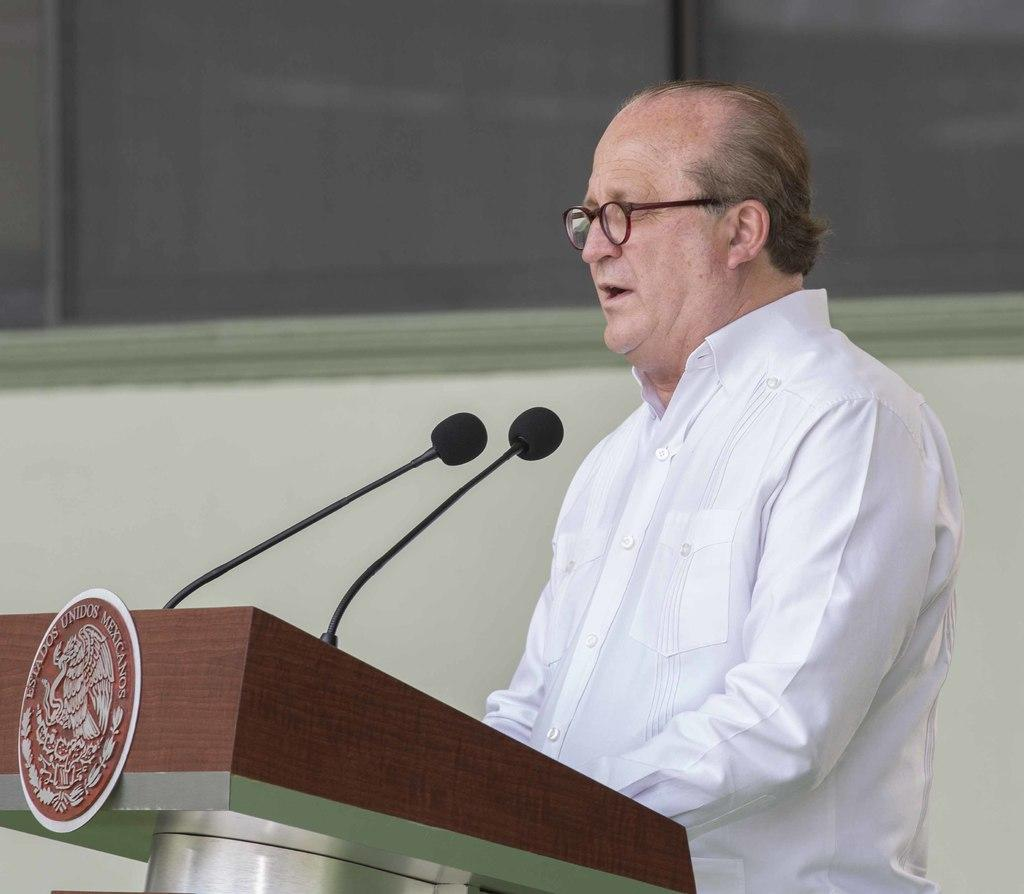What is the man doing near the podium in the image? The man is standing near a podium and speaking. What is the man wearing in the image? The man is wearing a white color shirt and spectacles. What type of umbrella is the man holding in the image? There is no umbrella present in the image. Can you tell me how many quarters the man is holding in his hand? There are no quarters visible in the image. 